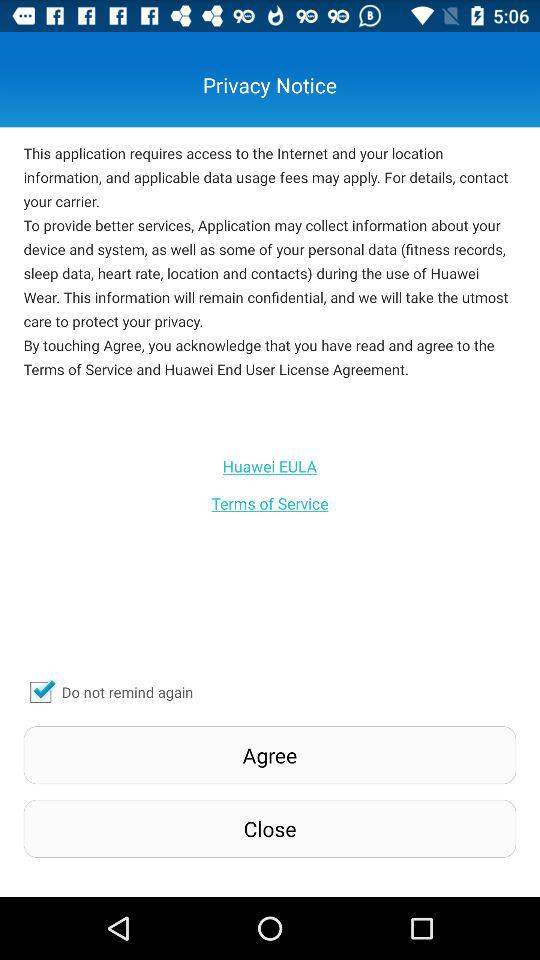What is the status of "Do not remind again"? The status of "Do not remind again" is "on". 